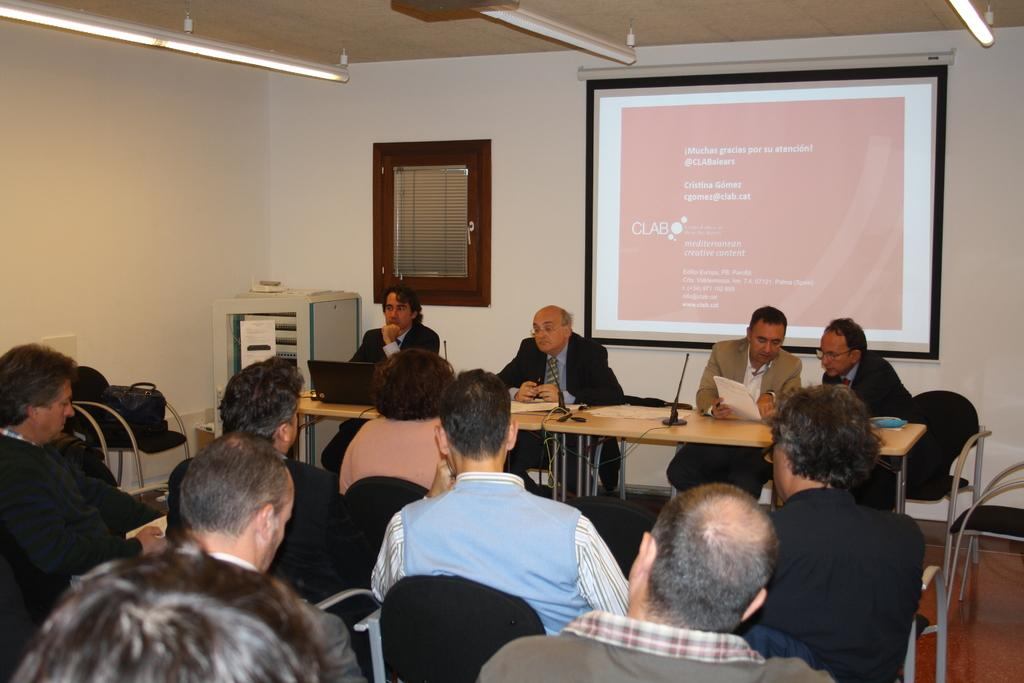What are the people in the image doing? The people in the image are sitting on chairs. What other objects can be seen in the image besides chairs? There are mice, tables, lights, a wall, and a screen in the image. What might the people be using the tables for? The tables could be used for various purposes, such as holding food, drinks, or other items. What provides illumination in the image? There are lights in the image that provide illumination. What type of field is visible in the image? There is no field present in the image. Who is the partner of the person sitting on the chair in the image? There is no indication of a partner or relationship between the people in the image. 